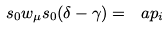<formula> <loc_0><loc_0><loc_500><loc_500>s _ { 0 } w _ { \mu } s _ { 0 } ( \delta - \gamma ) = \ a p _ { i }</formula> 